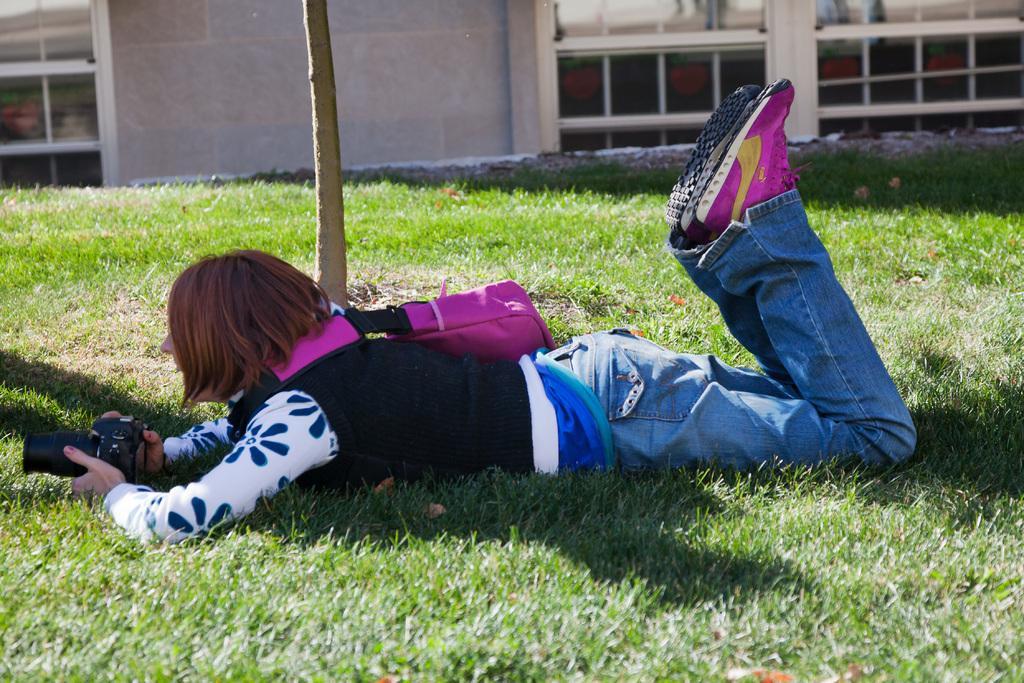Can you describe this image briefly? In the picture I can see a woman lying on the green grass and there is a camera in her hands. She is carrying a bag and there is a smile on her face. In the background, I can see the glass windows of a building. 